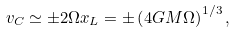<formula> <loc_0><loc_0><loc_500><loc_500>v _ { C } \simeq \pm 2 \Omega x _ { L } = \pm \left ( 4 G M \Omega \right ) ^ { 1 / 3 } ,</formula> 